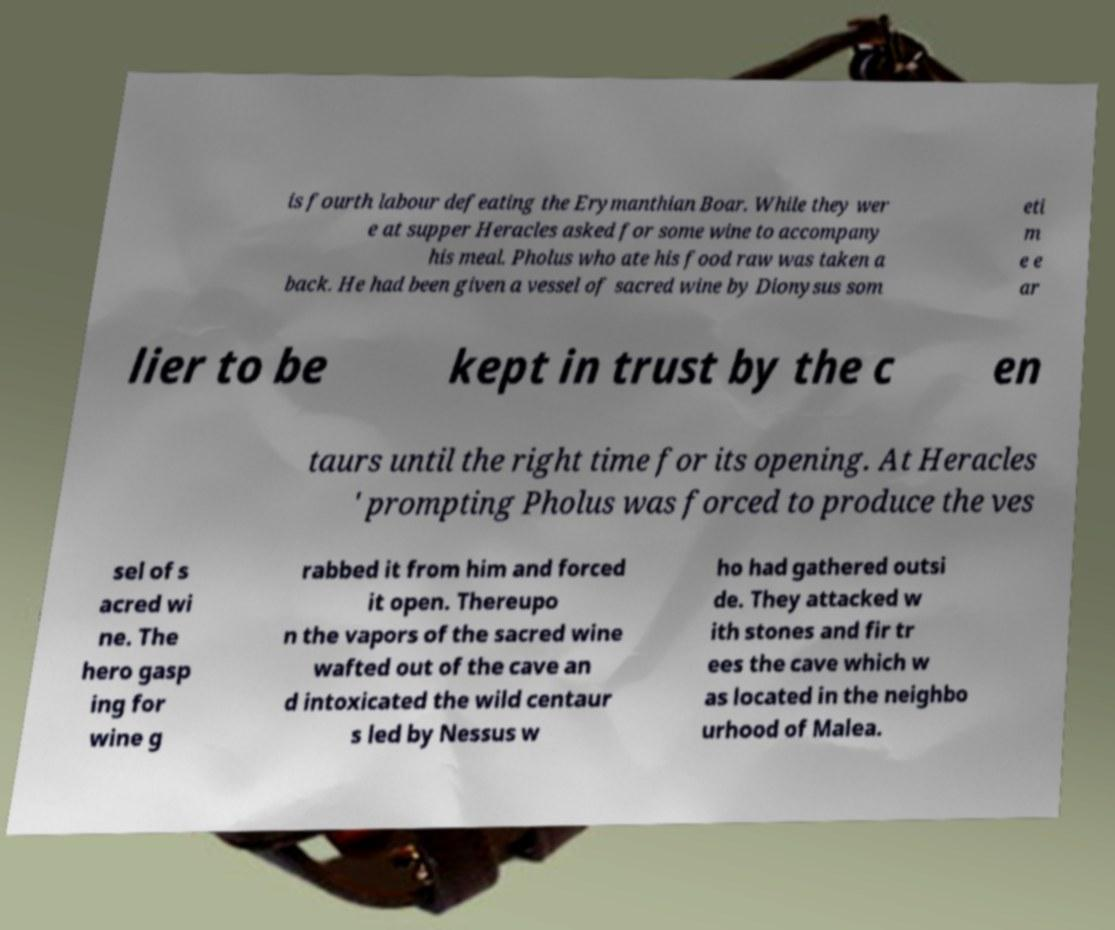Please read and relay the text visible in this image. What does it say? is fourth labour defeating the Erymanthian Boar. While they wer e at supper Heracles asked for some wine to accompany his meal. Pholus who ate his food raw was taken a back. He had been given a vessel of sacred wine by Dionysus som eti m e e ar lier to be kept in trust by the c en taurs until the right time for its opening. At Heracles ' prompting Pholus was forced to produce the ves sel of s acred wi ne. The hero gasp ing for wine g rabbed it from him and forced it open. Thereupo n the vapors of the sacred wine wafted out of the cave an d intoxicated the wild centaur s led by Nessus w ho had gathered outsi de. They attacked w ith stones and fir tr ees the cave which w as located in the neighbo urhood of Malea. 